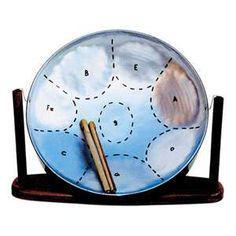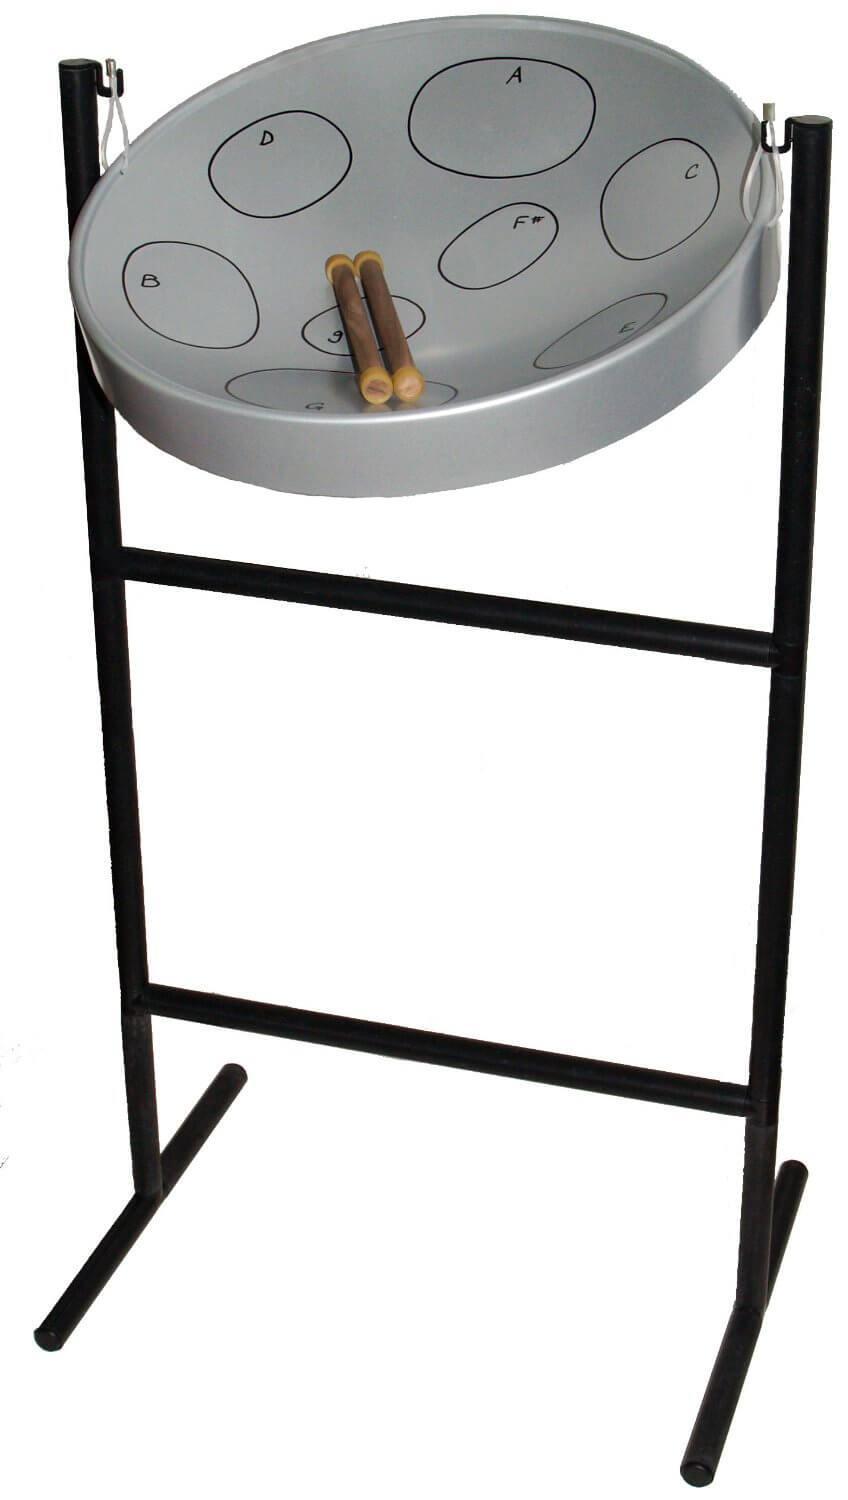The first image is the image on the left, the second image is the image on the right. Assess this claim about the two images: "The right image contains a single chrome metal drum with two drum sticks resting on top of the drum.". Correct or not? Answer yes or no. Yes. The first image is the image on the left, the second image is the image on the right. For the images displayed, is the sentence "The designs of two steel drums are different, as are their stands, but each has two sticks resting in the drum." factually correct? Answer yes or no. Yes. 